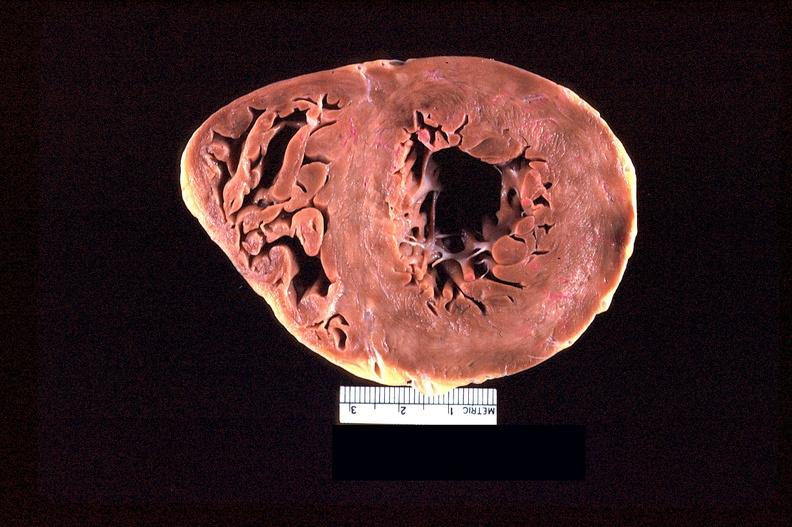where is this?
Answer the question using a single word or phrase. Heart 